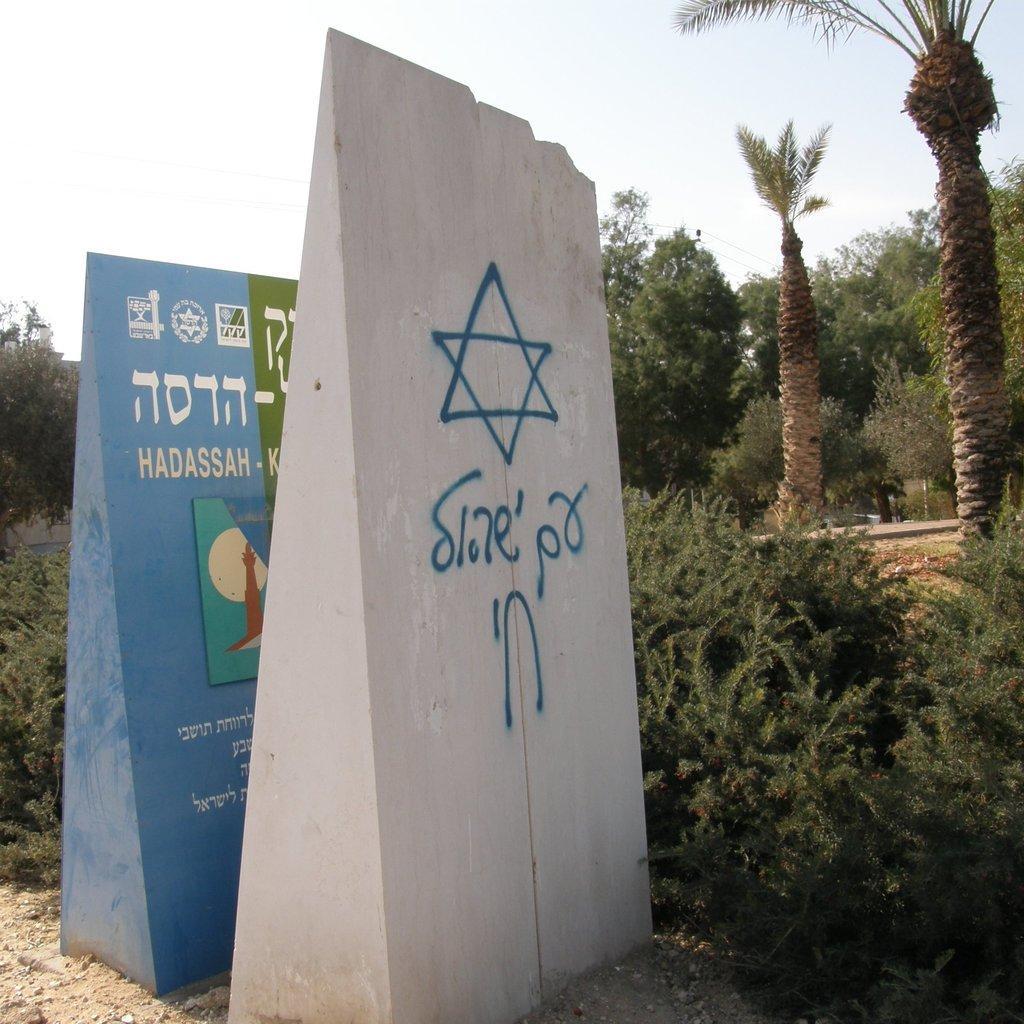How would you summarize this image in a sentence or two? In this image there are two wall structures with some text and images on it. In the background there are trees and the sky. 